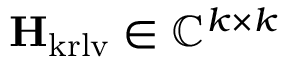Convert formula to latex. <formula><loc_0><loc_0><loc_500><loc_500>H _ { k r l v } \in \mathbb { C } ^ { k \times k }</formula> 